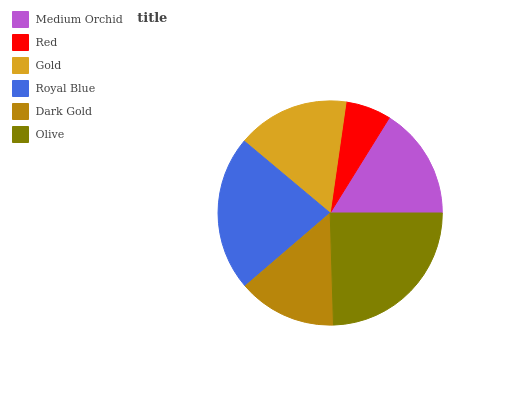Is Red the minimum?
Answer yes or no. Yes. Is Olive the maximum?
Answer yes or no. Yes. Is Gold the minimum?
Answer yes or no. No. Is Gold the maximum?
Answer yes or no. No. Is Gold greater than Red?
Answer yes or no. Yes. Is Red less than Gold?
Answer yes or no. Yes. Is Red greater than Gold?
Answer yes or no. No. Is Gold less than Red?
Answer yes or no. No. Is Gold the high median?
Answer yes or no. Yes. Is Medium Orchid the low median?
Answer yes or no. Yes. Is Royal Blue the high median?
Answer yes or no. No. Is Dark Gold the low median?
Answer yes or no. No. 